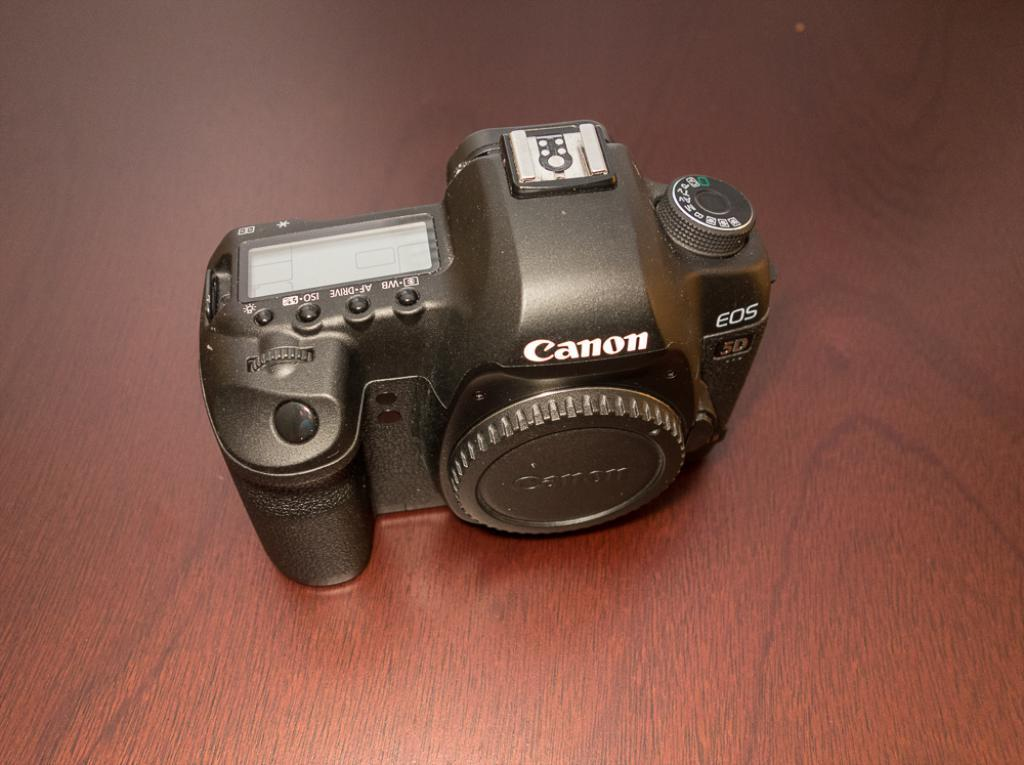What object is the main subject of the image? There is a camera in the image. What is the color of the camera? The camera is black in color. Is there any accessory attached to the camera? Yes, there is a lens cap attached to the camera. On what surface is the camera placed? The camera is placed on a brown surface. How many feet are visible in the image? There are no feet visible in the image; it features a camera with a lens cap on a brown surface. What type of distribution is being managed by the camera in the image? The image does not depict any distribution being managed by the camera; it simply shows the camera and its accessories. 